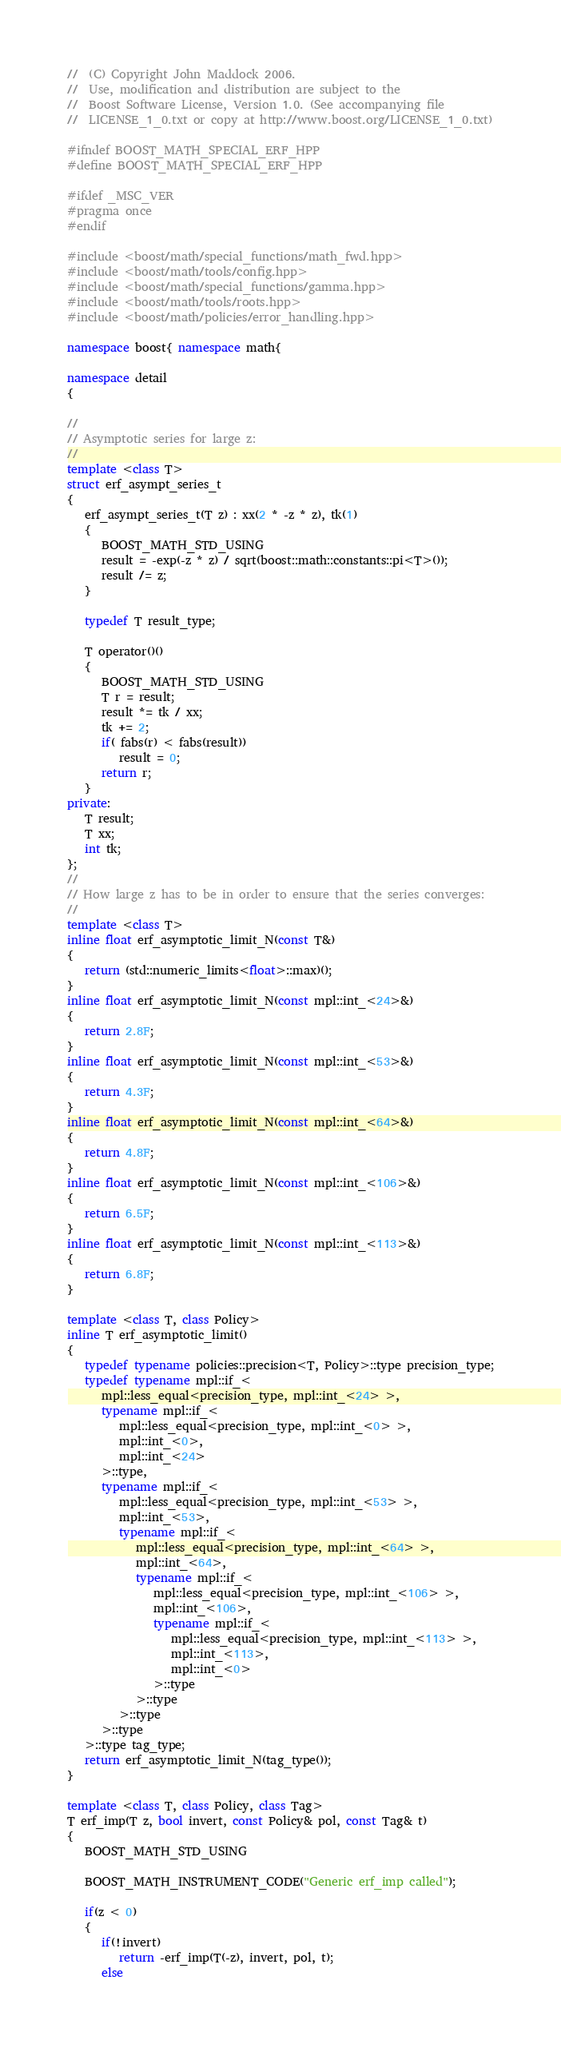Convert code to text. <code><loc_0><loc_0><loc_500><loc_500><_C++_>//  (C) Copyright John Maddock 2006.
//  Use, modification and distribution are subject to the
//  Boost Software License, Version 1.0. (See accompanying file
//  LICENSE_1_0.txt or copy at http://www.boost.org/LICENSE_1_0.txt)

#ifndef BOOST_MATH_SPECIAL_ERF_HPP
#define BOOST_MATH_SPECIAL_ERF_HPP

#ifdef _MSC_VER
#pragma once
#endif

#include <boost/math/special_functions/math_fwd.hpp>
#include <boost/math/tools/config.hpp>
#include <boost/math/special_functions/gamma.hpp>
#include <boost/math/tools/roots.hpp>
#include <boost/math/policies/error_handling.hpp>

namespace boost{ namespace math{

namespace detail
{

//
// Asymptotic series for large z:
//
template <class T>
struct erf_asympt_series_t
{
   erf_asympt_series_t(T z) : xx(2 * -z * z), tk(1)
   {
      BOOST_MATH_STD_USING
      result = -exp(-z * z) / sqrt(boost::math::constants::pi<T>());
      result /= z;
   }

   typedef T result_type;

   T operator()()
   {
      BOOST_MATH_STD_USING
      T r = result;
      result *= tk / xx;
      tk += 2;
      if( fabs(r) < fabs(result))
         result = 0;
      return r;
   }
private:
   T result;
   T xx;
   int tk;
};
//
// How large z has to be in order to ensure that the series converges:
//
template <class T>
inline float erf_asymptotic_limit_N(const T&)
{
   return (std::numeric_limits<float>::max)();
}
inline float erf_asymptotic_limit_N(const mpl::int_<24>&)
{
   return 2.8F;
}
inline float erf_asymptotic_limit_N(const mpl::int_<53>&)
{
   return 4.3F;
}
inline float erf_asymptotic_limit_N(const mpl::int_<64>&)
{
   return 4.8F;
}
inline float erf_asymptotic_limit_N(const mpl::int_<106>&)
{
   return 6.5F;
}
inline float erf_asymptotic_limit_N(const mpl::int_<113>&)
{
   return 6.8F;
}

template <class T, class Policy>
inline T erf_asymptotic_limit()
{
   typedef typename policies::precision<T, Policy>::type precision_type;
   typedef typename mpl::if_<
      mpl::less_equal<precision_type, mpl::int_<24> >,
      typename mpl::if_<
         mpl::less_equal<precision_type, mpl::int_<0> >,
         mpl::int_<0>,
         mpl::int_<24>
      >::type,
      typename mpl::if_<
         mpl::less_equal<precision_type, mpl::int_<53> >,
         mpl::int_<53>,
         typename mpl::if_<
            mpl::less_equal<precision_type, mpl::int_<64> >,
            mpl::int_<64>,
            typename mpl::if_<
               mpl::less_equal<precision_type, mpl::int_<106> >,
               mpl::int_<106>,
               typename mpl::if_<
                  mpl::less_equal<precision_type, mpl::int_<113> >,
                  mpl::int_<113>,
                  mpl::int_<0>
               >::type
            >::type
         >::type
      >::type
   >::type tag_type;
   return erf_asymptotic_limit_N(tag_type());
}

template <class T, class Policy, class Tag>
T erf_imp(T z, bool invert, const Policy& pol, const Tag& t)
{
   BOOST_MATH_STD_USING

   BOOST_MATH_INSTRUMENT_CODE("Generic erf_imp called");

   if(z < 0)
   {
      if(!invert)
         return -erf_imp(T(-z), invert, pol, t);
      else</code> 